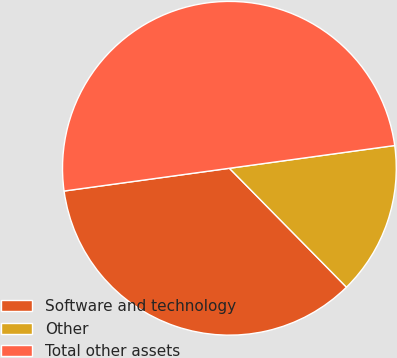Convert chart. <chart><loc_0><loc_0><loc_500><loc_500><pie_chart><fcel>Software and technology<fcel>Other<fcel>Total other assets<nl><fcel>35.2%<fcel>14.8%<fcel>50.0%<nl></chart> 